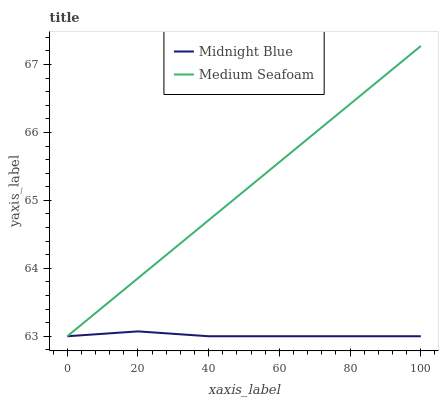Does Midnight Blue have the minimum area under the curve?
Answer yes or no. Yes. Does Medium Seafoam have the maximum area under the curve?
Answer yes or no. Yes. Does Medium Seafoam have the minimum area under the curve?
Answer yes or no. No. Is Medium Seafoam the smoothest?
Answer yes or no. Yes. Is Midnight Blue the roughest?
Answer yes or no. Yes. Is Medium Seafoam the roughest?
Answer yes or no. No. Does Midnight Blue have the lowest value?
Answer yes or no. Yes. Does Medium Seafoam have the highest value?
Answer yes or no. Yes. Does Midnight Blue intersect Medium Seafoam?
Answer yes or no. Yes. Is Midnight Blue less than Medium Seafoam?
Answer yes or no. No. Is Midnight Blue greater than Medium Seafoam?
Answer yes or no. No. 